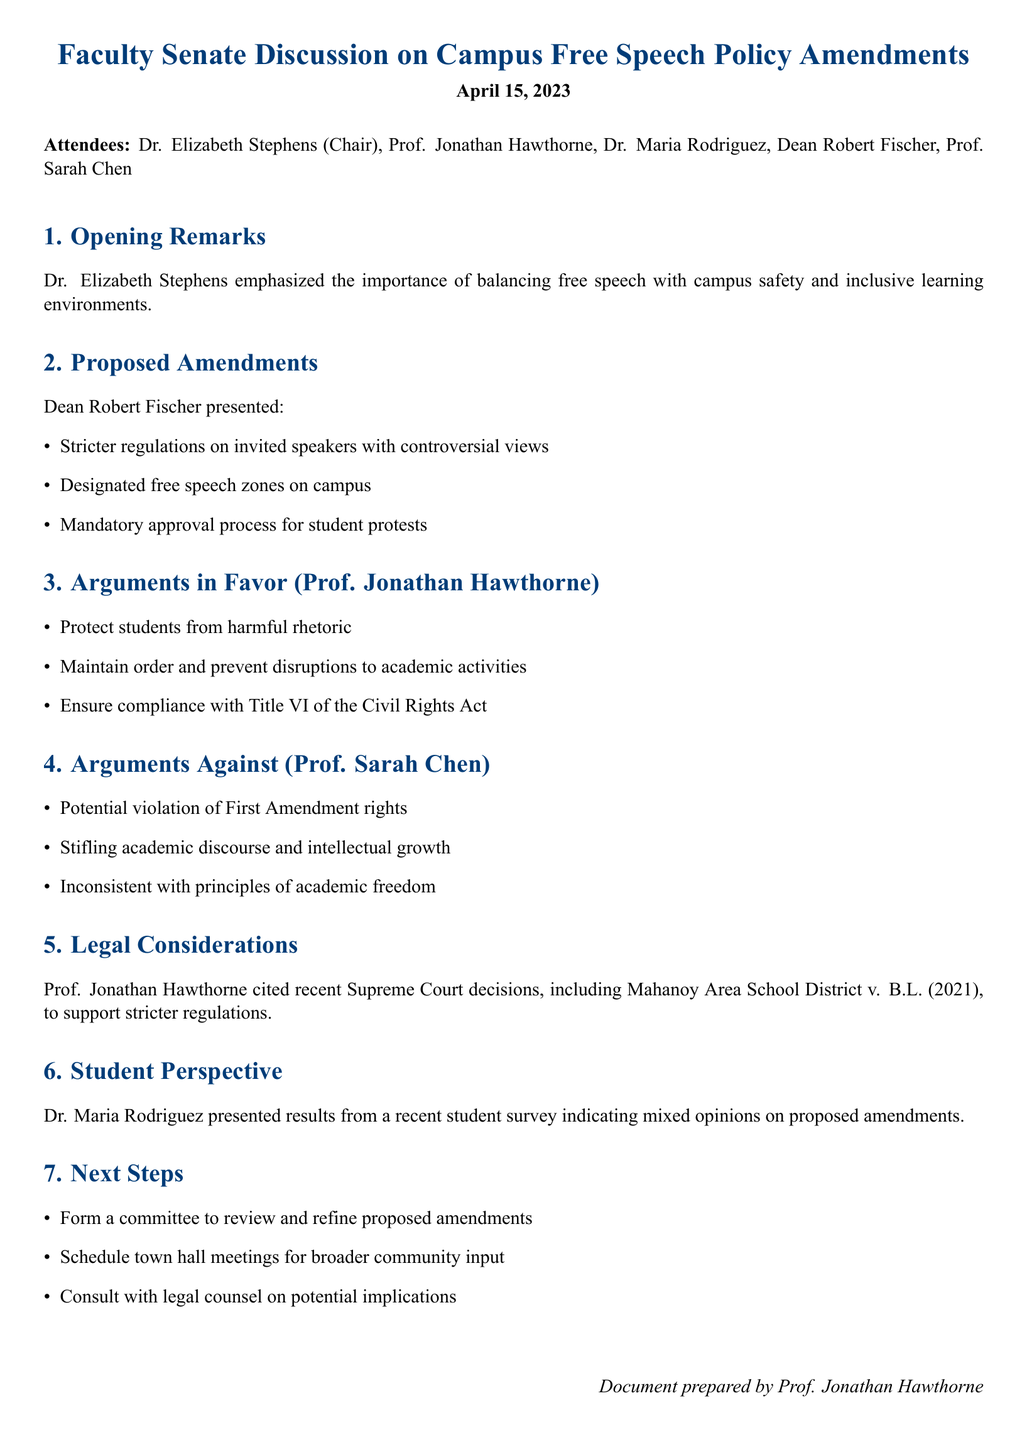What is the title of the meeting? The title of the meeting is prominently mentioned at the beginning of the document.
Answer: Faculty Senate Discussion on Campus Free Speech Policy Amendments Who chaired the meeting? The document lists attendees, including the chair of the meeting.
Answer: Dr. Elizabeth Stephens What date was the meeting held? The date of the meeting is provided in the opening section of the document.
Answer: April 15, 2023 What is one proposed amendment regarding invited speakers? The proposed amendments include specific regulations which are listed.
Answer: Stricter regulations on invited speakers with controversial views What argument did Prof. Jonathan Hawthorne make in favor of the amendments? The document outlines key points from various speakers; one supporting argument is mentioned.
Answer: Protect students from harmful rhetoric What argument did Prof. Sarah Chen make against the amendments? The document highlights arguments from different speakers, including reasons against the proposed changes.
Answer: Potential violation of First Amendment rights What did Dr. Maria Rodriguez present? The contributions of each presenter, including survey results, are detailed in the document.
Answer: Student survey indicating mixed opinions What is one action item for the next steps? The document lists several action items decided upon at the end of the meeting.
Answer: Form a committee to review and refine proposed amendments 